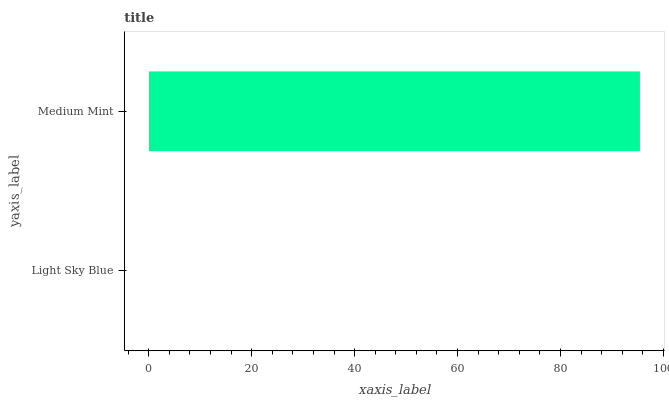Is Light Sky Blue the minimum?
Answer yes or no. Yes. Is Medium Mint the maximum?
Answer yes or no. Yes. Is Medium Mint the minimum?
Answer yes or no. No. Is Medium Mint greater than Light Sky Blue?
Answer yes or no. Yes. Is Light Sky Blue less than Medium Mint?
Answer yes or no. Yes. Is Light Sky Blue greater than Medium Mint?
Answer yes or no. No. Is Medium Mint less than Light Sky Blue?
Answer yes or no. No. Is Medium Mint the high median?
Answer yes or no. Yes. Is Light Sky Blue the low median?
Answer yes or no. Yes. Is Light Sky Blue the high median?
Answer yes or no. No. Is Medium Mint the low median?
Answer yes or no. No. 